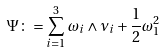<formula> <loc_0><loc_0><loc_500><loc_500>\Psi \colon = \sum _ { i = 1 } ^ { 3 } \omega _ { i } \wedge \nu _ { i } + \frac { 1 } { 2 } \omega _ { 1 } ^ { 2 }</formula> 